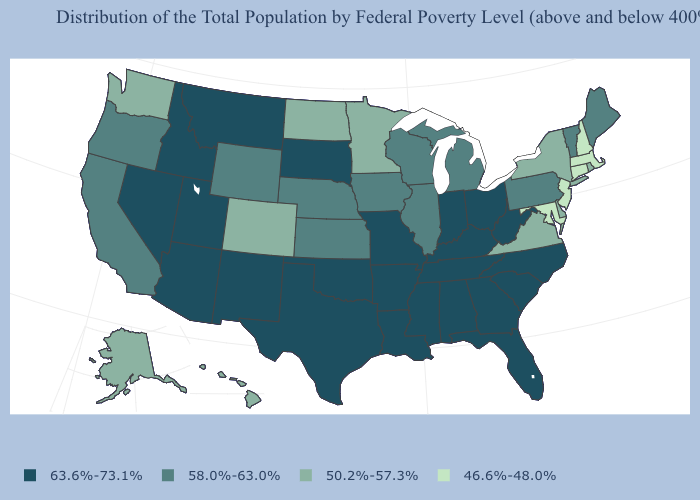Name the states that have a value in the range 50.2%-57.3%?
Concise answer only. Alaska, Colorado, Delaware, Hawaii, Minnesota, New York, North Dakota, Rhode Island, Virginia, Washington. How many symbols are there in the legend?
Keep it brief. 4. Which states have the highest value in the USA?
Keep it brief. Alabama, Arizona, Arkansas, Florida, Georgia, Idaho, Indiana, Kentucky, Louisiana, Mississippi, Missouri, Montana, Nevada, New Mexico, North Carolina, Ohio, Oklahoma, South Carolina, South Dakota, Tennessee, Texas, Utah, West Virginia. What is the value of Oklahoma?
Answer briefly. 63.6%-73.1%. Name the states that have a value in the range 58.0%-63.0%?
Write a very short answer. California, Illinois, Iowa, Kansas, Maine, Michigan, Nebraska, Oregon, Pennsylvania, Vermont, Wisconsin, Wyoming. What is the highest value in the USA?
Keep it brief. 63.6%-73.1%. Does Arkansas have a higher value than New Mexico?
Answer briefly. No. Among the states that border Massachusetts , does New Hampshire have the lowest value?
Give a very brief answer. Yes. What is the value of Pennsylvania?
Short answer required. 58.0%-63.0%. What is the value of North Dakota?
Give a very brief answer. 50.2%-57.3%. What is the value of Arizona?
Give a very brief answer. 63.6%-73.1%. What is the value of North Dakota?
Write a very short answer. 50.2%-57.3%. What is the lowest value in the West?
Quick response, please. 50.2%-57.3%. Name the states that have a value in the range 46.6%-48.0%?
Answer briefly. Connecticut, Maryland, Massachusetts, New Hampshire, New Jersey. 